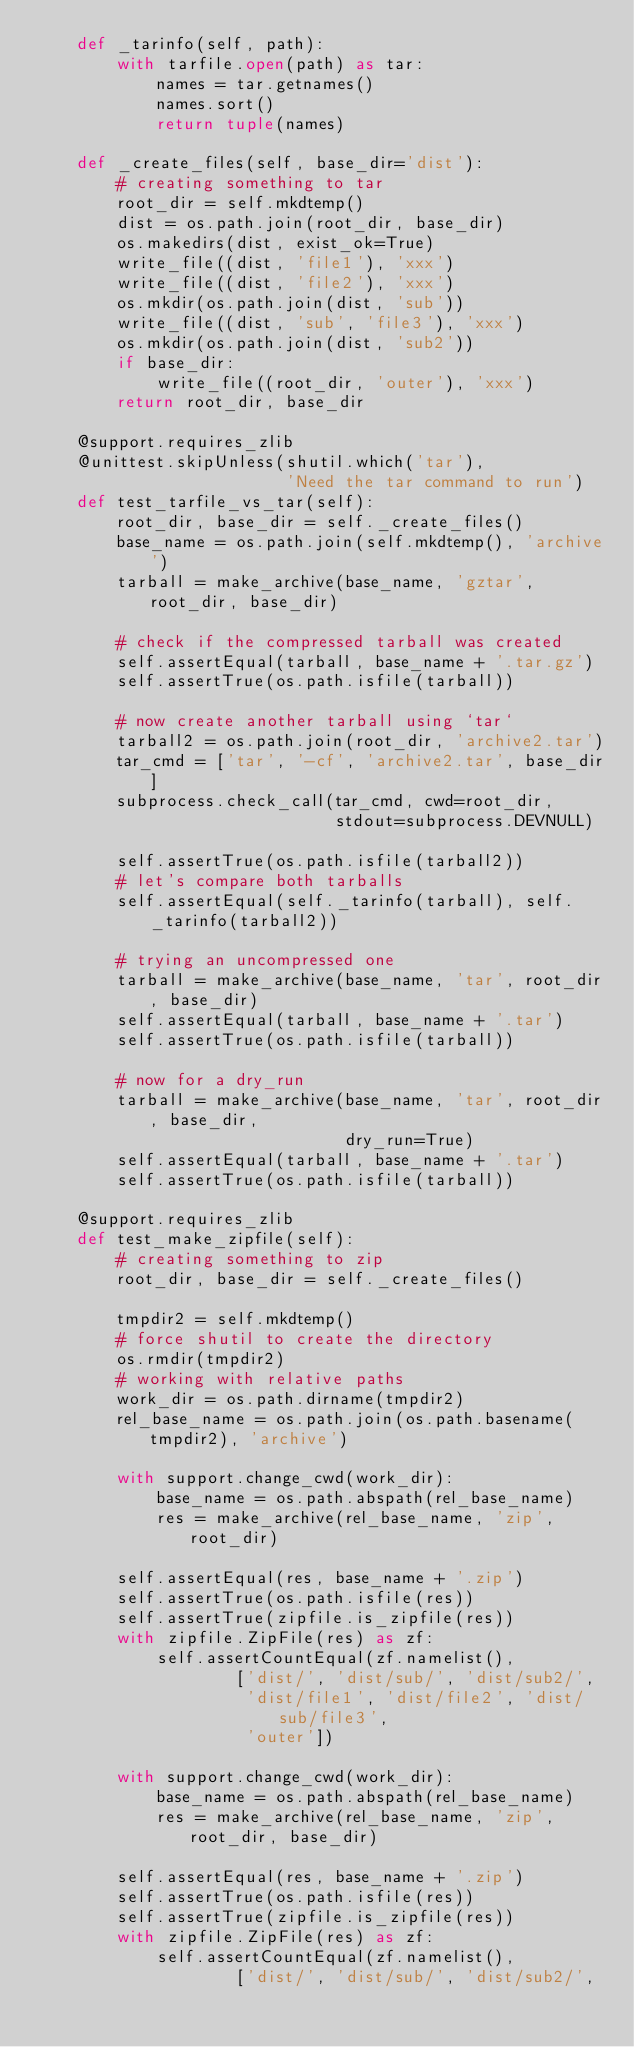Convert code to text. <code><loc_0><loc_0><loc_500><loc_500><_Python_>    def _tarinfo(self, path):
        with tarfile.open(path) as tar:
            names = tar.getnames()
            names.sort()
            return tuple(names)

    def _create_files(self, base_dir='dist'):
        # creating something to tar
        root_dir = self.mkdtemp()
        dist = os.path.join(root_dir, base_dir)
        os.makedirs(dist, exist_ok=True)
        write_file((dist, 'file1'), 'xxx')
        write_file((dist, 'file2'), 'xxx')
        os.mkdir(os.path.join(dist, 'sub'))
        write_file((dist, 'sub', 'file3'), 'xxx')
        os.mkdir(os.path.join(dist, 'sub2'))
        if base_dir:
            write_file((root_dir, 'outer'), 'xxx')
        return root_dir, base_dir

    @support.requires_zlib
    @unittest.skipUnless(shutil.which('tar'),
                         'Need the tar command to run')
    def test_tarfile_vs_tar(self):
        root_dir, base_dir = self._create_files()
        base_name = os.path.join(self.mkdtemp(), 'archive')
        tarball = make_archive(base_name, 'gztar', root_dir, base_dir)

        # check if the compressed tarball was created
        self.assertEqual(tarball, base_name + '.tar.gz')
        self.assertTrue(os.path.isfile(tarball))

        # now create another tarball using `tar`
        tarball2 = os.path.join(root_dir, 'archive2.tar')
        tar_cmd = ['tar', '-cf', 'archive2.tar', base_dir]
        subprocess.check_call(tar_cmd, cwd=root_dir,
                              stdout=subprocess.DEVNULL)

        self.assertTrue(os.path.isfile(tarball2))
        # let's compare both tarballs
        self.assertEqual(self._tarinfo(tarball), self._tarinfo(tarball2))

        # trying an uncompressed one
        tarball = make_archive(base_name, 'tar', root_dir, base_dir)
        self.assertEqual(tarball, base_name + '.tar')
        self.assertTrue(os.path.isfile(tarball))

        # now for a dry_run
        tarball = make_archive(base_name, 'tar', root_dir, base_dir,
                               dry_run=True)
        self.assertEqual(tarball, base_name + '.tar')
        self.assertTrue(os.path.isfile(tarball))

    @support.requires_zlib
    def test_make_zipfile(self):
        # creating something to zip
        root_dir, base_dir = self._create_files()

        tmpdir2 = self.mkdtemp()
        # force shutil to create the directory
        os.rmdir(tmpdir2)
        # working with relative paths
        work_dir = os.path.dirname(tmpdir2)
        rel_base_name = os.path.join(os.path.basename(tmpdir2), 'archive')

        with support.change_cwd(work_dir):
            base_name = os.path.abspath(rel_base_name)
            res = make_archive(rel_base_name, 'zip', root_dir)

        self.assertEqual(res, base_name + '.zip')
        self.assertTrue(os.path.isfile(res))
        self.assertTrue(zipfile.is_zipfile(res))
        with zipfile.ZipFile(res) as zf:
            self.assertCountEqual(zf.namelist(),
                    ['dist/', 'dist/sub/', 'dist/sub2/',
                     'dist/file1', 'dist/file2', 'dist/sub/file3',
                     'outer'])

        with support.change_cwd(work_dir):
            base_name = os.path.abspath(rel_base_name)
            res = make_archive(rel_base_name, 'zip', root_dir, base_dir)

        self.assertEqual(res, base_name + '.zip')
        self.assertTrue(os.path.isfile(res))
        self.assertTrue(zipfile.is_zipfile(res))
        with zipfile.ZipFile(res) as zf:
            self.assertCountEqual(zf.namelist(),
                    ['dist/', 'dist/sub/', 'dist/sub2/',</code> 